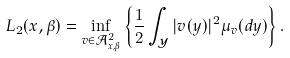Convert formula to latex. <formula><loc_0><loc_0><loc_500><loc_500>L _ { 2 } ( x , \beta ) = \inf _ { v \in \mathcal { A } _ { x , \beta } ^ { 2 } } \left \{ \frac { 1 } { 2 } \int _ { \mathcal { Y } } | v ( y ) | ^ { 2 } \mu _ { v } ( d y ) \right \} .</formula> 